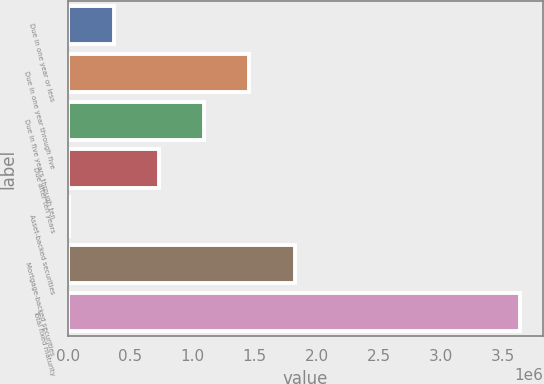Convert chart. <chart><loc_0><loc_0><loc_500><loc_500><bar_chart><fcel>Due in one year or less<fcel>Due in one year through five<fcel>Due in five years through ten<fcel>Due after ten years<fcel>Asset-backed securities<fcel>Mortgage-backed securities<fcel>Total fixed maturity<nl><fcel>368676<fcel>1.45822e+06<fcel>1.09504e+06<fcel>731857<fcel>5494<fcel>1.8214e+06<fcel>3.63731e+06<nl></chart> 